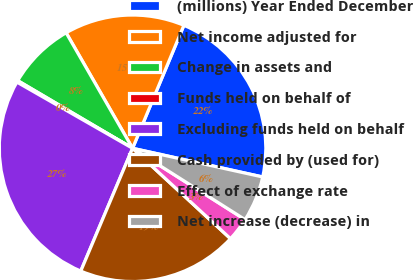Convert chart to OTSL. <chart><loc_0><loc_0><loc_500><loc_500><pie_chart><fcel>(millions) Year Ended December<fcel>Net income adjusted for<fcel>Change in assets and<fcel>Funds held on behalf of<fcel>Excluding funds held on behalf<fcel>Cash provided by (used for)<fcel>Effect of exchange rate<fcel>Net increase (decrease) in<nl><fcel>22.16%<fcel>14.6%<fcel>8.22%<fcel>0.2%<fcel>26.92%<fcel>19.49%<fcel>2.87%<fcel>5.54%<nl></chart> 